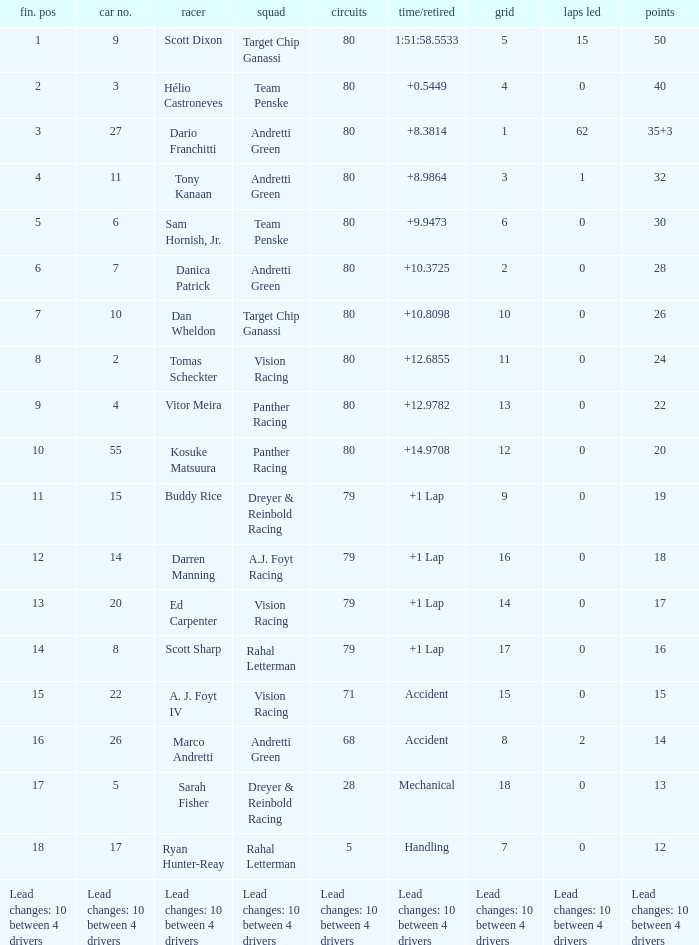Which team has 26 points? Target Chip Ganassi. 